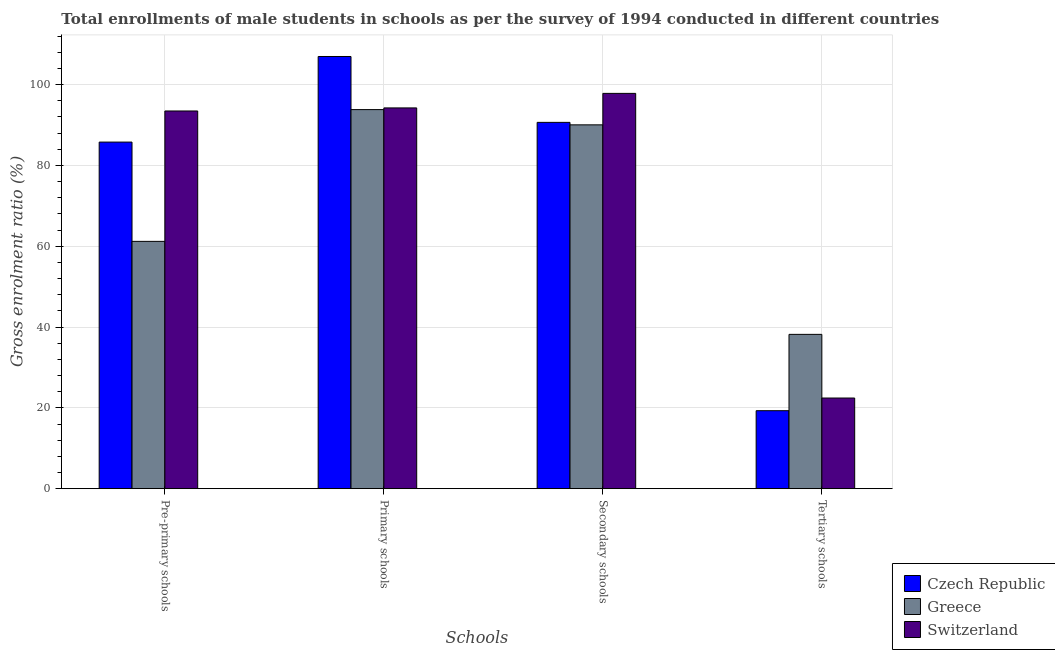How many groups of bars are there?
Keep it short and to the point. 4. How many bars are there on the 3rd tick from the right?
Your answer should be very brief. 3. What is the label of the 4th group of bars from the left?
Your answer should be very brief. Tertiary schools. What is the gross enrolment ratio(male) in pre-primary schools in Greece?
Your answer should be very brief. 61.19. Across all countries, what is the maximum gross enrolment ratio(male) in secondary schools?
Keep it short and to the point. 97.81. Across all countries, what is the minimum gross enrolment ratio(male) in primary schools?
Keep it short and to the point. 93.8. In which country was the gross enrolment ratio(male) in pre-primary schools maximum?
Provide a short and direct response. Switzerland. In which country was the gross enrolment ratio(male) in primary schools minimum?
Provide a succinct answer. Greece. What is the total gross enrolment ratio(male) in tertiary schools in the graph?
Your answer should be very brief. 79.91. What is the difference between the gross enrolment ratio(male) in tertiary schools in Switzerland and that in Greece?
Offer a terse response. -15.75. What is the difference between the gross enrolment ratio(male) in pre-primary schools in Greece and the gross enrolment ratio(male) in primary schools in Switzerland?
Your answer should be compact. -33.03. What is the average gross enrolment ratio(male) in secondary schools per country?
Your response must be concise. 92.83. What is the difference between the gross enrolment ratio(male) in secondary schools and gross enrolment ratio(male) in tertiary schools in Switzerland?
Your response must be concise. 75.38. In how many countries, is the gross enrolment ratio(male) in tertiary schools greater than 40 %?
Provide a succinct answer. 0. What is the ratio of the gross enrolment ratio(male) in primary schools in Czech Republic to that in Switzerland?
Your answer should be compact. 1.14. Is the difference between the gross enrolment ratio(male) in secondary schools in Switzerland and Greece greater than the difference between the gross enrolment ratio(male) in pre-primary schools in Switzerland and Greece?
Your answer should be very brief. No. What is the difference between the highest and the second highest gross enrolment ratio(male) in primary schools?
Keep it short and to the point. 12.72. What is the difference between the highest and the lowest gross enrolment ratio(male) in pre-primary schools?
Offer a terse response. 32.26. In how many countries, is the gross enrolment ratio(male) in primary schools greater than the average gross enrolment ratio(male) in primary schools taken over all countries?
Make the answer very short. 1. Is the sum of the gross enrolment ratio(male) in primary schools in Greece and Switzerland greater than the maximum gross enrolment ratio(male) in pre-primary schools across all countries?
Offer a very short reply. Yes. What does the 3rd bar from the left in Pre-primary schools represents?
Make the answer very short. Switzerland. What does the 3rd bar from the right in Secondary schools represents?
Provide a short and direct response. Czech Republic. Is it the case that in every country, the sum of the gross enrolment ratio(male) in pre-primary schools and gross enrolment ratio(male) in primary schools is greater than the gross enrolment ratio(male) in secondary schools?
Make the answer very short. Yes. How many bars are there?
Provide a succinct answer. 12. Are all the bars in the graph horizontal?
Give a very brief answer. No. How many countries are there in the graph?
Give a very brief answer. 3. What is the difference between two consecutive major ticks on the Y-axis?
Offer a terse response. 20. Are the values on the major ticks of Y-axis written in scientific E-notation?
Keep it short and to the point. No. Does the graph contain any zero values?
Provide a succinct answer. No. Where does the legend appear in the graph?
Provide a succinct answer. Bottom right. How are the legend labels stacked?
Provide a short and direct response. Vertical. What is the title of the graph?
Give a very brief answer. Total enrollments of male students in schools as per the survey of 1994 conducted in different countries. What is the label or title of the X-axis?
Provide a succinct answer. Schools. What is the Gross enrolment ratio (%) of Czech Republic in Pre-primary schools?
Your answer should be very brief. 85.76. What is the Gross enrolment ratio (%) in Greece in Pre-primary schools?
Offer a terse response. 61.19. What is the Gross enrolment ratio (%) in Switzerland in Pre-primary schools?
Give a very brief answer. 93.46. What is the Gross enrolment ratio (%) of Czech Republic in Primary schools?
Keep it short and to the point. 106.94. What is the Gross enrolment ratio (%) in Greece in Primary schools?
Your answer should be compact. 93.8. What is the Gross enrolment ratio (%) in Switzerland in Primary schools?
Give a very brief answer. 94.22. What is the Gross enrolment ratio (%) in Czech Republic in Secondary schools?
Give a very brief answer. 90.64. What is the Gross enrolment ratio (%) in Greece in Secondary schools?
Keep it short and to the point. 90.03. What is the Gross enrolment ratio (%) of Switzerland in Secondary schools?
Offer a very short reply. 97.81. What is the Gross enrolment ratio (%) of Czech Republic in Tertiary schools?
Provide a short and direct response. 19.3. What is the Gross enrolment ratio (%) in Greece in Tertiary schools?
Keep it short and to the point. 38.18. What is the Gross enrolment ratio (%) in Switzerland in Tertiary schools?
Make the answer very short. 22.43. Across all Schools, what is the maximum Gross enrolment ratio (%) of Czech Republic?
Your answer should be very brief. 106.94. Across all Schools, what is the maximum Gross enrolment ratio (%) in Greece?
Keep it short and to the point. 93.8. Across all Schools, what is the maximum Gross enrolment ratio (%) of Switzerland?
Provide a succinct answer. 97.81. Across all Schools, what is the minimum Gross enrolment ratio (%) of Czech Republic?
Make the answer very short. 19.3. Across all Schools, what is the minimum Gross enrolment ratio (%) in Greece?
Your answer should be very brief. 38.18. Across all Schools, what is the minimum Gross enrolment ratio (%) in Switzerland?
Your answer should be very brief. 22.43. What is the total Gross enrolment ratio (%) of Czech Republic in the graph?
Make the answer very short. 302.64. What is the total Gross enrolment ratio (%) in Greece in the graph?
Provide a short and direct response. 283.21. What is the total Gross enrolment ratio (%) of Switzerland in the graph?
Your answer should be compact. 307.92. What is the difference between the Gross enrolment ratio (%) in Czech Republic in Pre-primary schools and that in Primary schools?
Your answer should be compact. -21.18. What is the difference between the Gross enrolment ratio (%) of Greece in Pre-primary schools and that in Primary schools?
Your response must be concise. -32.61. What is the difference between the Gross enrolment ratio (%) in Switzerland in Pre-primary schools and that in Primary schools?
Your answer should be compact. -0.76. What is the difference between the Gross enrolment ratio (%) in Czech Republic in Pre-primary schools and that in Secondary schools?
Ensure brevity in your answer.  -4.88. What is the difference between the Gross enrolment ratio (%) in Greece in Pre-primary schools and that in Secondary schools?
Ensure brevity in your answer.  -28.83. What is the difference between the Gross enrolment ratio (%) in Switzerland in Pre-primary schools and that in Secondary schools?
Your response must be concise. -4.36. What is the difference between the Gross enrolment ratio (%) in Czech Republic in Pre-primary schools and that in Tertiary schools?
Give a very brief answer. 66.47. What is the difference between the Gross enrolment ratio (%) of Greece in Pre-primary schools and that in Tertiary schools?
Provide a succinct answer. 23.01. What is the difference between the Gross enrolment ratio (%) in Switzerland in Pre-primary schools and that in Tertiary schools?
Your response must be concise. 71.03. What is the difference between the Gross enrolment ratio (%) of Czech Republic in Primary schools and that in Secondary schools?
Provide a succinct answer. 16.3. What is the difference between the Gross enrolment ratio (%) in Greece in Primary schools and that in Secondary schools?
Your answer should be compact. 3.77. What is the difference between the Gross enrolment ratio (%) in Switzerland in Primary schools and that in Secondary schools?
Your response must be concise. -3.6. What is the difference between the Gross enrolment ratio (%) in Czech Republic in Primary schools and that in Tertiary schools?
Your response must be concise. 87.65. What is the difference between the Gross enrolment ratio (%) of Greece in Primary schools and that in Tertiary schools?
Offer a terse response. 55.62. What is the difference between the Gross enrolment ratio (%) in Switzerland in Primary schools and that in Tertiary schools?
Offer a terse response. 71.79. What is the difference between the Gross enrolment ratio (%) in Czech Republic in Secondary schools and that in Tertiary schools?
Your answer should be very brief. 71.34. What is the difference between the Gross enrolment ratio (%) of Greece in Secondary schools and that in Tertiary schools?
Ensure brevity in your answer.  51.85. What is the difference between the Gross enrolment ratio (%) of Switzerland in Secondary schools and that in Tertiary schools?
Provide a short and direct response. 75.38. What is the difference between the Gross enrolment ratio (%) in Czech Republic in Pre-primary schools and the Gross enrolment ratio (%) in Greece in Primary schools?
Your response must be concise. -8.04. What is the difference between the Gross enrolment ratio (%) of Czech Republic in Pre-primary schools and the Gross enrolment ratio (%) of Switzerland in Primary schools?
Provide a short and direct response. -8.46. What is the difference between the Gross enrolment ratio (%) of Greece in Pre-primary schools and the Gross enrolment ratio (%) of Switzerland in Primary schools?
Keep it short and to the point. -33.03. What is the difference between the Gross enrolment ratio (%) of Czech Republic in Pre-primary schools and the Gross enrolment ratio (%) of Greece in Secondary schools?
Offer a terse response. -4.27. What is the difference between the Gross enrolment ratio (%) of Czech Republic in Pre-primary schools and the Gross enrolment ratio (%) of Switzerland in Secondary schools?
Make the answer very short. -12.05. What is the difference between the Gross enrolment ratio (%) in Greece in Pre-primary schools and the Gross enrolment ratio (%) in Switzerland in Secondary schools?
Make the answer very short. -36.62. What is the difference between the Gross enrolment ratio (%) in Czech Republic in Pre-primary schools and the Gross enrolment ratio (%) in Greece in Tertiary schools?
Offer a very short reply. 47.58. What is the difference between the Gross enrolment ratio (%) of Czech Republic in Pre-primary schools and the Gross enrolment ratio (%) of Switzerland in Tertiary schools?
Ensure brevity in your answer.  63.33. What is the difference between the Gross enrolment ratio (%) in Greece in Pre-primary schools and the Gross enrolment ratio (%) in Switzerland in Tertiary schools?
Offer a very short reply. 38.76. What is the difference between the Gross enrolment ratio (%) of Czech Republic in Primary schools and the Gross enrolment ratio (%) of Greece in Secondary schools?
Ensure brevity in your answer.  16.92. What is the difference between the Gross enrolment ratio (%) in Czech Republic in Primary schools and the Gross enrolment ratio (%) in Switzerland in Secondary schools?
Provide a short and direct response. 9.13. What is the difference between the Gross enrolment ratio (%) in Greece in Primary schools and the Gross enrolment ratio (%) in Switzerland in Secondary schools?
Your answer should be compact. -4.01. What is the difference between the Gross enrolment ratio (%) in Czech Republic in Primary schools and the Gross enrolment ratio (%) in Greece in Tertiary schools?
Ensure brevity in your answer.  68.76. What is the difference between the Gross enrolment ratio (%) of Czech Republic in Primary schools and the Gross enrolment ratio (%) of Switzerland in Tertiary schools?
Ensure brevity in your answer.  84.51. What is the difference between the Gross enrolment ratio (%) in Greece in Primary schools and the Gross enrolment ratio (%) in Switzerland in Tertiary schools?
Provide a short and direct response. 71.37. What is the difference between the Gross enrolment ratio (%) in Czech Republic in Secondary schools and the Gross enrolment ratio (%) in Greece in Tertiary schools?
Make the answer very short. 52.46. What is the difference between the Gross enrolment ratio (%) in Czech Republic in Secondary schools and the Gross enrolment ratio (%) in Switzerland in Tertiary schools?
Offer a very short reply. 68.21. What is the difference between the Gross enrolment ratio (%) in Greece in Secondary schools and the Gross enrolment ratio (%) in Switzerland in Tertiary schools?
Your answer should be compact. 67.6. What is the average Gross enrolment ratio (%) of Czech Republic per Schools?
Provide a succinct answer. 75.66. What is the average Gross enrolment ratio (%) of Greece per Schools?
Your response must be concise. 70.8. What is the average Gross enrolment ratio (%) in Switzerland per Schools?
Keep it short and to the point. 76.98. What is the difference between the Gross enrolment ratio (%) in Czech Republic and Gross enrolment ratio (%) in Greece in Pre-primary schools?
Ensure brevity in your answer.  24.57. What is the difference between the Gross enrolment ratio (%) in Czech Republic and Gross enrolment ratio (%) in Switzerland in Pre-primary schools?
Offer a very short reply. -7.7. What is the difference between the Gross enrolment ratio (%) of Greece and Gross enrolment ratio (%) of Switzerland in Pre-primary schools?
Make the answer very short. -32.26. What is the difference between the Gross enrolment ratio (%) of Czech Republic and Gross enrolment ratio (%) of Greece in Primary schools?
Your answer should be very brief. 13.14. What is the difference between the Gross enrolment ratio (%) of Czech Republic and Gross enrolment ratio (%) of Switzerland in Primary schools?
Offer a terse response. 12.72. What is the difference between the Gross enrolment ratio (%) of Greece and Gross enrolment ratio (%) of Switzerland in Primary schools?
Keep it short and to the point. -0.42. What is the difference between the Gross enrolment ratio (%) of Czech Republic and Gross enrolment ratio (%) of Greece in Secondary schools?
Your answer should be very brief. 0.61. What is the difference between the Gross enrolment ratio (%) of Czech Republic and Gross enrolment ratio (%) of Switzerland in Secondary schools?
Provide a succinct answer. -7.17. What is the difference between the Gross enrolment ratio (%) of Greece and Gross enrolment ratio (%) of Switzerland in Secondary schools?
Provide a short and direct response. -7.79. What is the difference between the Gross enrolment ratio (%) in Czech Republic and Gross enrolment ratio (%) in Greece in Tertiary schools?
Provide a succinct answer. -18.89. What is the difference between the Gross enrolment ratio (%) of Czech Republic and Gross enrolment ratio (%) of Switzerland in Tertiary schools?
Offer a terse response. -3.13. What is the difference between the Gross enrolment ratio (%) in Greece and Gross enrolment ratio (%) in Switzerland in Tertiary schools?
Ensure brevity in your answer.  15.75. What is the ratio of the Gross enrolment ratio (%) of Czech Republic in Pre-primary schools to that in Primary schools?
Make the answer very short. 0.8. What is the ratio of the Gross enrolment ratio (%) of Greece in Pre-primary schools to that in Primary schools?
Offer a terse response. 0.65. What is the ratio of the Gross enrolment ratio (%) of Switzerland in Pre-primary schools to that in Primary schools?
Your response must be concise. 0.99. What is the ratio of the Gross enrolment ratio (%) of Czech Republic in Pre-primary schools to that in Secondary schools?
Your answer should be very brief. 0.95. What is the ratio of the Gross enrolment ratio (%) in Greece in Pre-primary schools to that in Secondary schools?
Give a very brief answer. 0.68. What is the ratio of the Gross enrolment ratio (%) of Switzerland in Pre-primary schools to that in Secondary schools?
Make the answer very short. 0.96. What is the ratio of the Gross enrolment ratio (%) of Czech Republic in Pre-primary schools to that in Tertiary schools?
Provide a short and direct response. 4.44. What is the ratio of the Gross enrolment ratio (%) in Greece in Pre-primary schools to that in Tertiary schools?
Your answer should be very brief. 1.6. What is the ratio of the Gross enrolment ratio (%) of Switzerland in Pre-primary schools to that in Tertiary schools?
Ensure brevity in your answer.  4.17. What is the ratio of the Gross enrolment ratio (%) of Czech Republic in Primary schools to that in Secondary schools?
Your answer should be very brief. 1.18. What is the ratio of the Gross enrolment ratio (%) in Greece in Primary schools to that in Secondary schools?
Ensure brevity in your answer.  1.04. What is the ratio of the Gross enrolment ratio (%) of Switzerland in Primary schools to that in Secondary schools?
Ensure brevity in your answer.  0.96. What is the ratio of the Gross enrolment ratio (%) in Czech Republic in Primary schools to that in Tertiary schools?
Keep it short and to the point. 5.54. What is the ratio of the Gross enrolment ratio (%) in Greece in Primary schools to that in Tertiary schools?
Offer a very short reply. 2.46. What is the ratio of the Gross enrolment ratio (%) in Switzerland in Primary schools to that in Tertiary schools?
Offer a very short reply. 4.2. What is the ratio of the Gross enrolment ratio (%) of Czech Republic in Secondary schools to that in Tertiary schools?
Offer a very short reply. 4.7. What is the ratio of the Gross enrolment ratio (%) of Greece in Secondary schools to that in Tertiary schools?
Offer a very short reply. 2.36. What is the ratio of the Gross enrolment ratio (%) in Switzerland in Secondary schools to that in Tertiary schools?
Your answer should be compact. 4.36. What is the difference between the highest and the second highest Gross enrolment ratio (%) in Czech Republic?
Offer a very short reply. 16.3. What is the difference between the highest and the second highest Gross enrolment ratio (%) in Greece?
Your response must be concise. 3.77. What is the difference between the highest and the second highest Gross enrolment ratio (%) in Switzerland?
Provide a succinct answer. 3.6. What is the difference between the highest and the lowest Gross enrolment ratio (%) of Czech Republic?
Your answer should be compact. 87.65. What is the difference between the highest and the lowest Gross enrolment ratio (%) in Greece?
Provide a short and direct response. 55.62. What is the difference between the highest and the lowest Gross enrolment ratio (%) of Switzerland?
Provide a short and direct response. 75.38. 